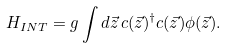<formula> <loc_0><loc_0><loc_500><loc_500>H _ { I N T } = g \int d \vec { z } \, c ( \vec { z } ) ^ { \dagger } c ( \vec { z } ) \phi ( \vec { z } ) .</formula> 